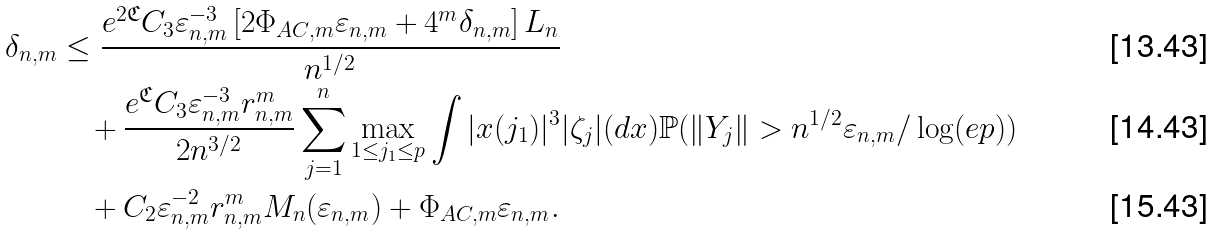Convert formula to latex. <formula><loc_0><loc_0><loc_500><loc_500>\delta _ { n , m } & \leq \frac { e ^ { 2 \mathfrak { C } } C _ { 3 } \varepsilon _ { n , m } ^ { - 3 } \left [ { 2 \Phi _ { A C , m } \varepsilon _ { n , m } } + { 4 ^ { m } \delta _ { n , m } } \right ] L _ { n } } { n ^ { 1 / 2 } } \\ & \quad + \frac { e ^ { \mathfrak { C } } C _ { 3 } \varepsilon _ { n , m } ^ { - 3 } r _ { n , m } ^ { m } } { 2 n ^ { 3 / 2 } } \sum _ { j = 1 } ^ { n } \max _ { 1 \leq j _ { 1 } \leq p } \int | x ( j _ { 1 } ) | ^ { 3 } | \zeta _ { j } | ( d x ) \mathbb { P } ( \| Y _ { j } \| > n ^ { 1 / 2 } \varepsilon _ { n , m } / \log ( e p ) ) \\ & \quad + { C _ { 2 } \varepsilon _ { n , m } ^ { - 2 } r ^ { m } _ { n , m } } M _ { n } ( \varepsilon _ { n , m } ) + \Phi _ { A C , m } \varepsilon _ { n , m } .</formula> 